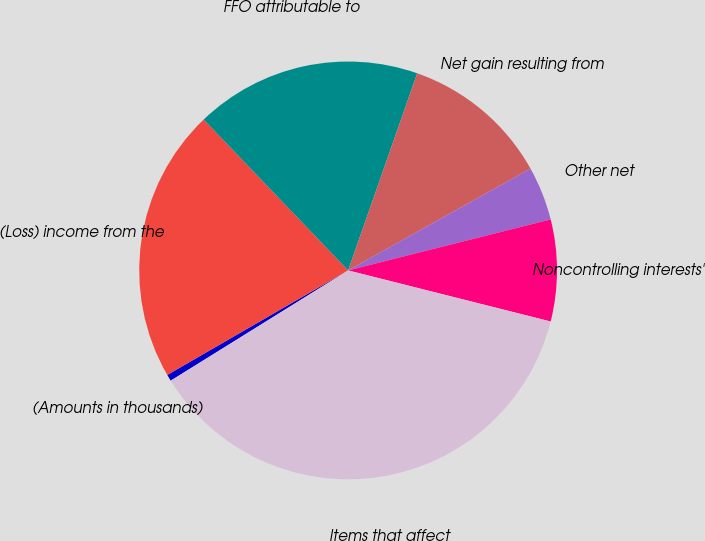<chart> <loc_0><loc_0><loc_500><loc_500><pie_chart><fcel>(Amounts in thousands)<fcel>(Loss) income from the<fcel>FFO attributable to<fcel>Net gain resulting from<fcel>Other net<fcel>Noncontrolling interests'<fcel>Items that affect<nl><fcel>0.51%<fcel>21.19%<fcel>17.52%<fcel>11.53%<fcel>4.18%<fcel>7.86%<fcel>37.22%<nl></chart> 